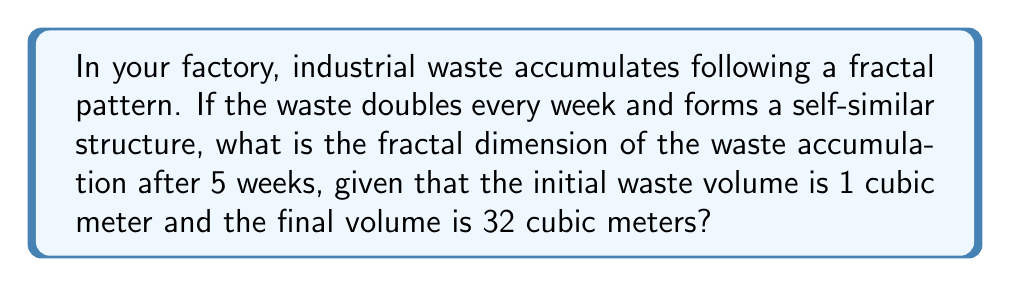Help me with this question. Let's approach this step-by-step:

1) First, we need to understand what fractal dimension represents. It's a measure of how the detail in a pattern changes with the scale at which it is measured.

2) For self-similar fractals, we can use the following formula:

   $$D = \frac{\log N}{\log r}$$

   Where:
   $D$ is the fractal dimension
   $N$ is the number of self-similar pieces
   $r$ is the scaling factor

3) In this case:
   - The waste doubles every week, so after 5 weeks, we have $2^5 = 32$ times the initial amount.
   - The initial volume is 1 cubic meter, and the final volume is 32 cubic meters.

4) The scaling factor $r$ is the ratio of the final volume to the initial volume:

   $$r = \frac{32}{1} = 32 = 2^5$$

5) The number of self-similar pieces $N$ is also 32, as the waste doubles 5 times.

6) Now we can plug these values into our formula:

   $$D = \frac{\log 32}{\log 32} = \frac{\log 2^5}{\log 2^5} = 1$$

7) Therefore, the fractal dimension of the waste accumulation is 1.
Answer: 1 